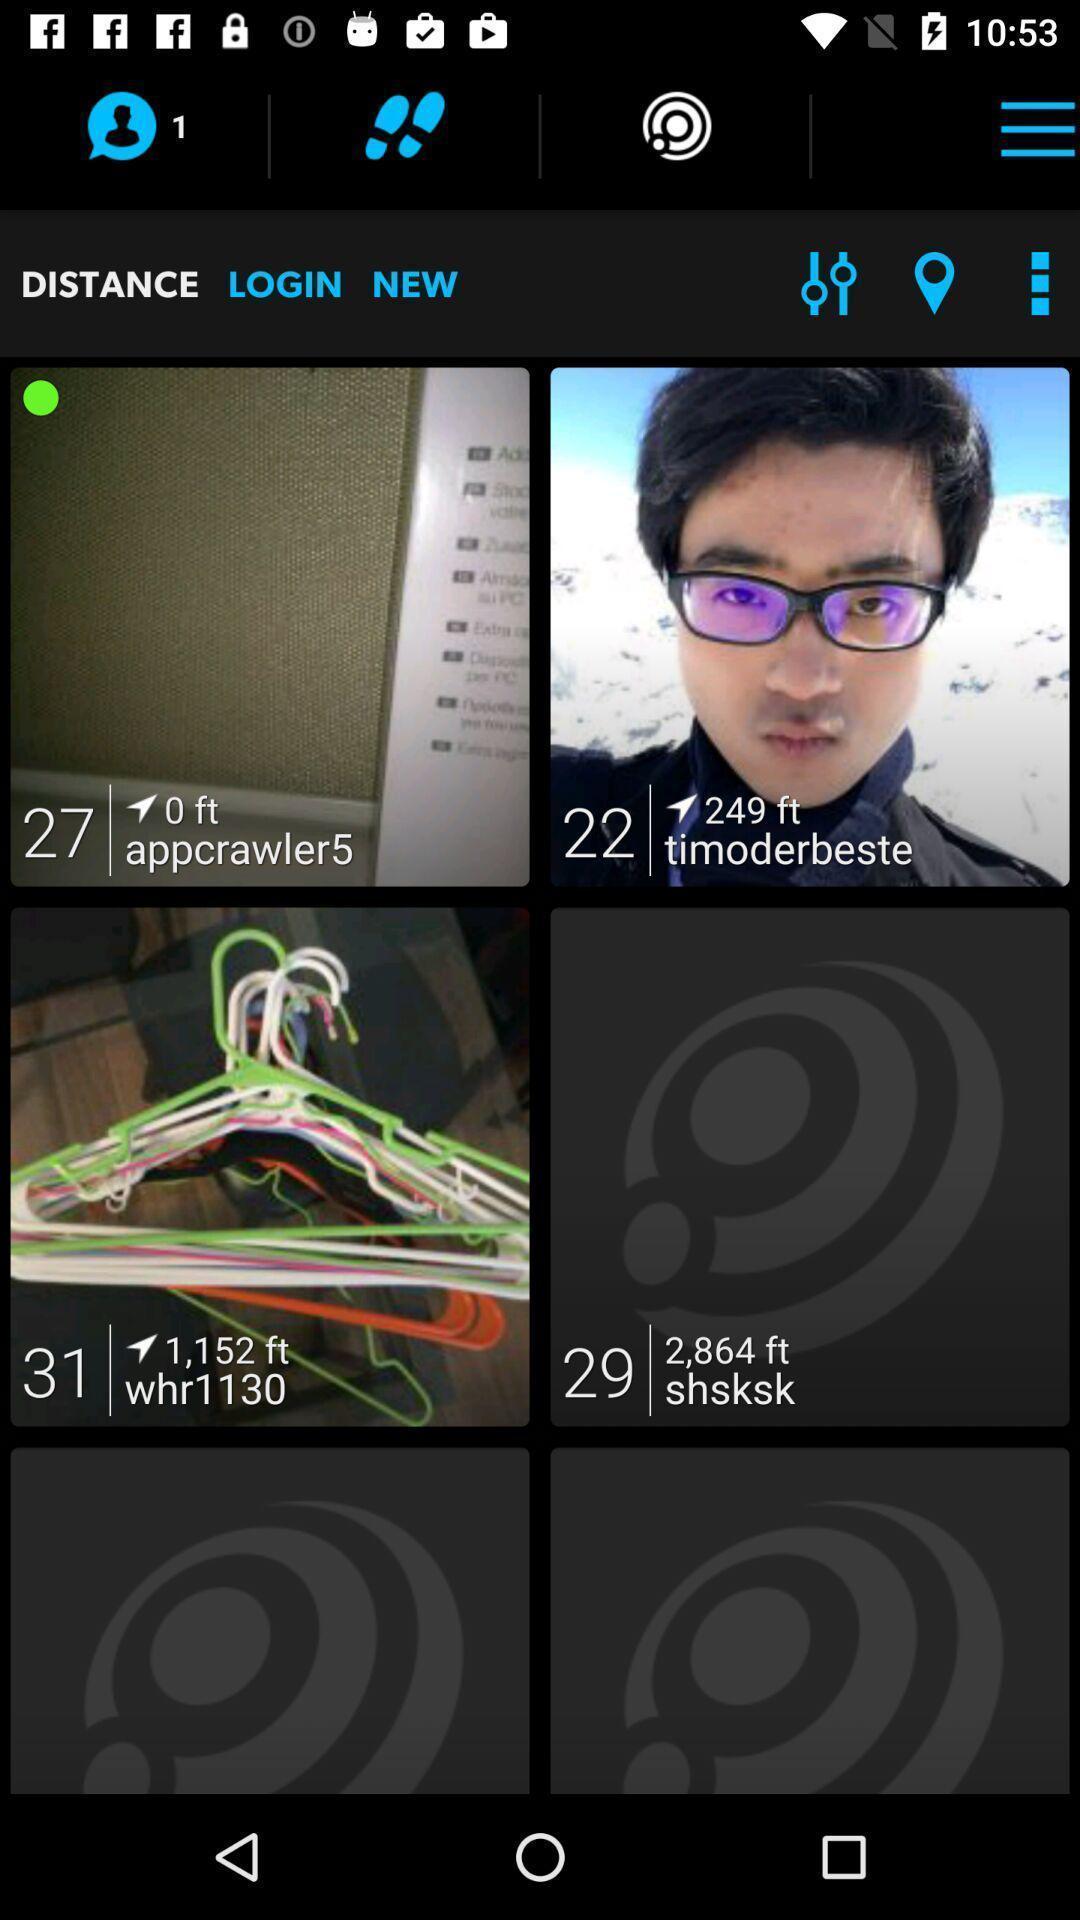Summarize the information in this screenshot. Screen shows different options in a social app. 